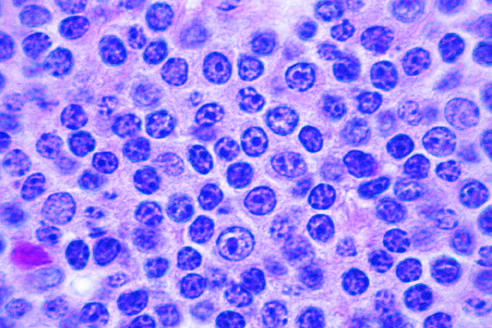s sci transl present in this field?
Answer the question using a single word or phrase. No 